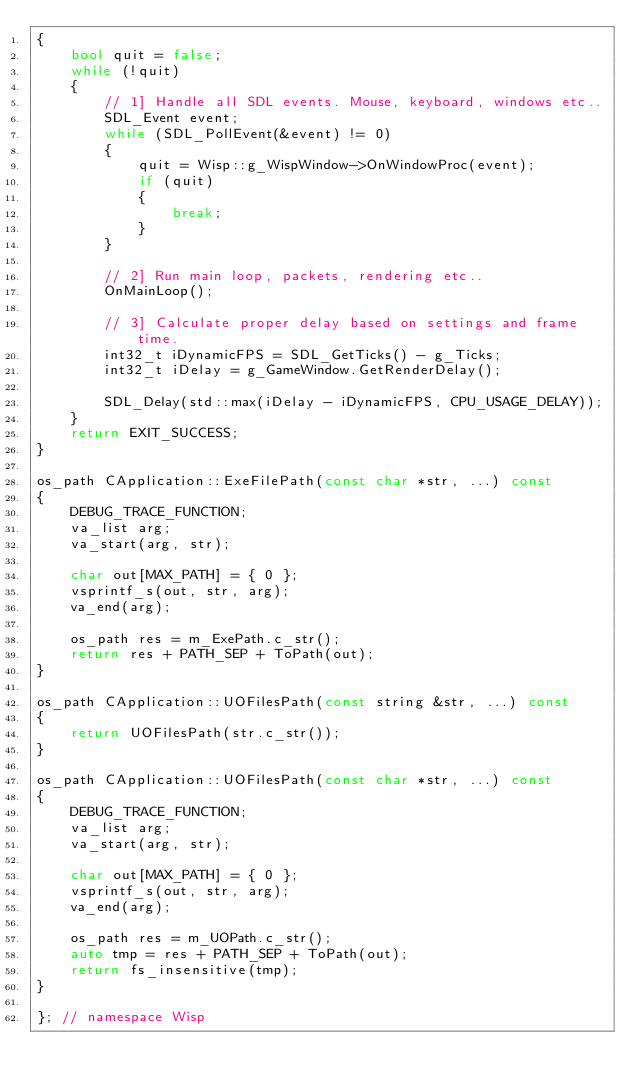<code> <loc_0><loc_0><loc_500><loc_500><_C++_>{
    bool quit = false;
    while (!quit)
    {
        // 1] Handle all SDL events. Mouse, keyboard, windows etc..
        SDL_Event event;
        while (SDL_PollEvent(&event) != 0)
        {
            quit = Wisp::g_WispWindow->OnWindowProc(event);
            if (quit)
            {
                break;
            }
        }

        // 2] Run main loop, packets, rendering etc..
        OnMainLoop();

        // 3] Calculate proper delay based on settings and frame time.
        int32_t iDynamicFPS = SDL_GetTicks() - g_Ticks;
        int32_t iDelay = g_GameWindow.GetRenderDelay();

        SDL_Delay(std::max(iDelay - iDynamicFPS, CPU_USAGE_DELAY));
    }
    return EXIT_SUCCESS;
}

os_path CApplication::ExeFilePath(const char *str, ...) const
{
    DEBUG_TRACE_FUNCTION;
    va_list arg;
    va_start(arg, str);

    char out[MAX_PATH] = { 0 };
    vsprintf_s(out, str, arg);
    va_end(arg);

    os_path res = m_ExePath.c_str();
    return res + PATH_SEP + ToPath(out);
}

os_path CApplication::UOFilesPath(const string &str, ...) const
{
    return UOFilesPath(str.c_str());
}

os_path CApplication::UOFilesPath(const char *str, ...) const
{
    DEBUG_TRACE_FUNCTION;
    va_list arg;
    va_start(arg, str);

    char out[MAX_PATH] = { 0 };
    vsprintf_s(out, str, arg);
    va_end(arg);

    os_path res = m_UOPath.c_str();
    auto tmp = res + PATH_SEP + ToPath(out);
    return fs_insensitive(tmp);
}

}; // namespace Wisp
</code> 